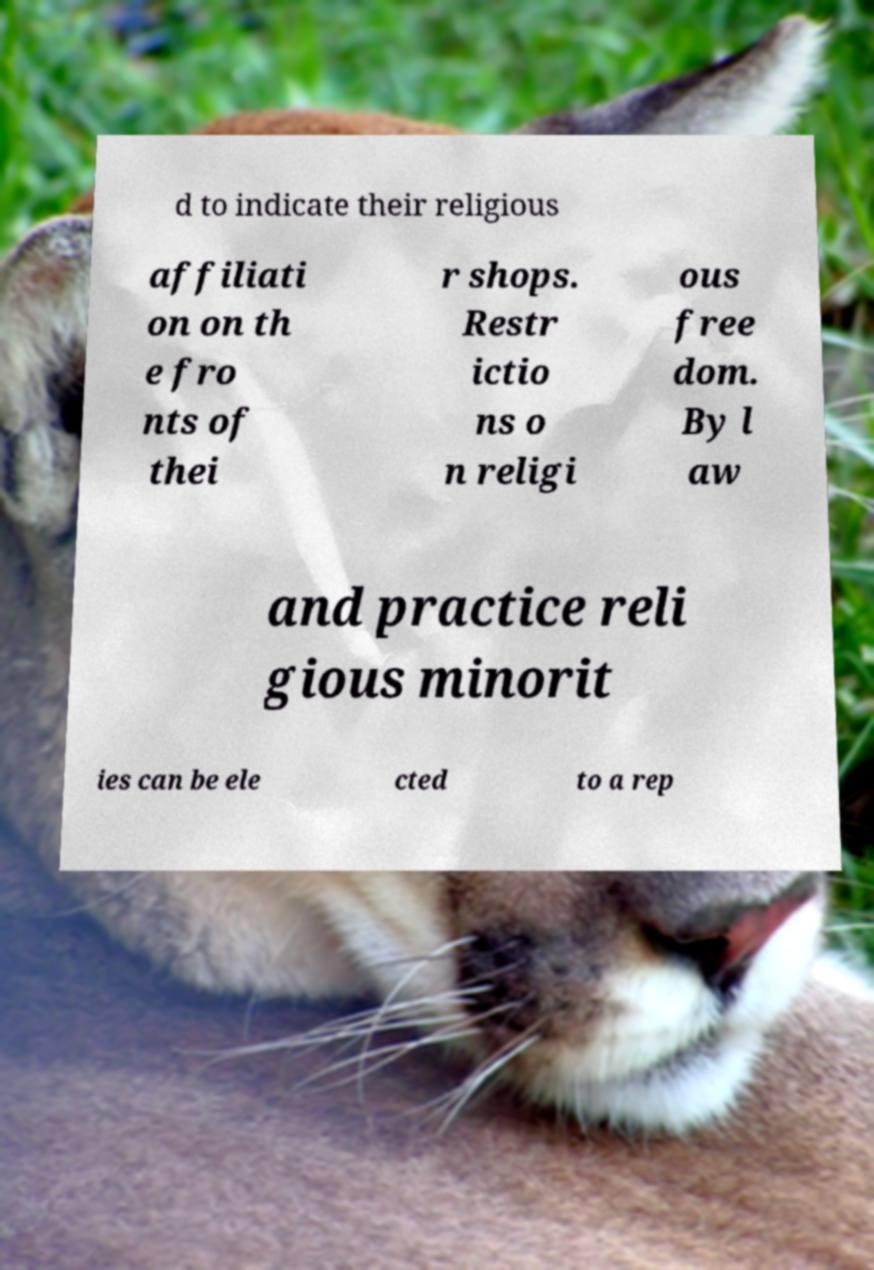I need the written content from this picture converted into text. Can you do that? d to indicate their religious affiliati on on th e fro nts of thei r shops. Restr ictio ns o n religi ous free dom. By l aw and practice reli gious minorit ies can be ele cted to a rep 